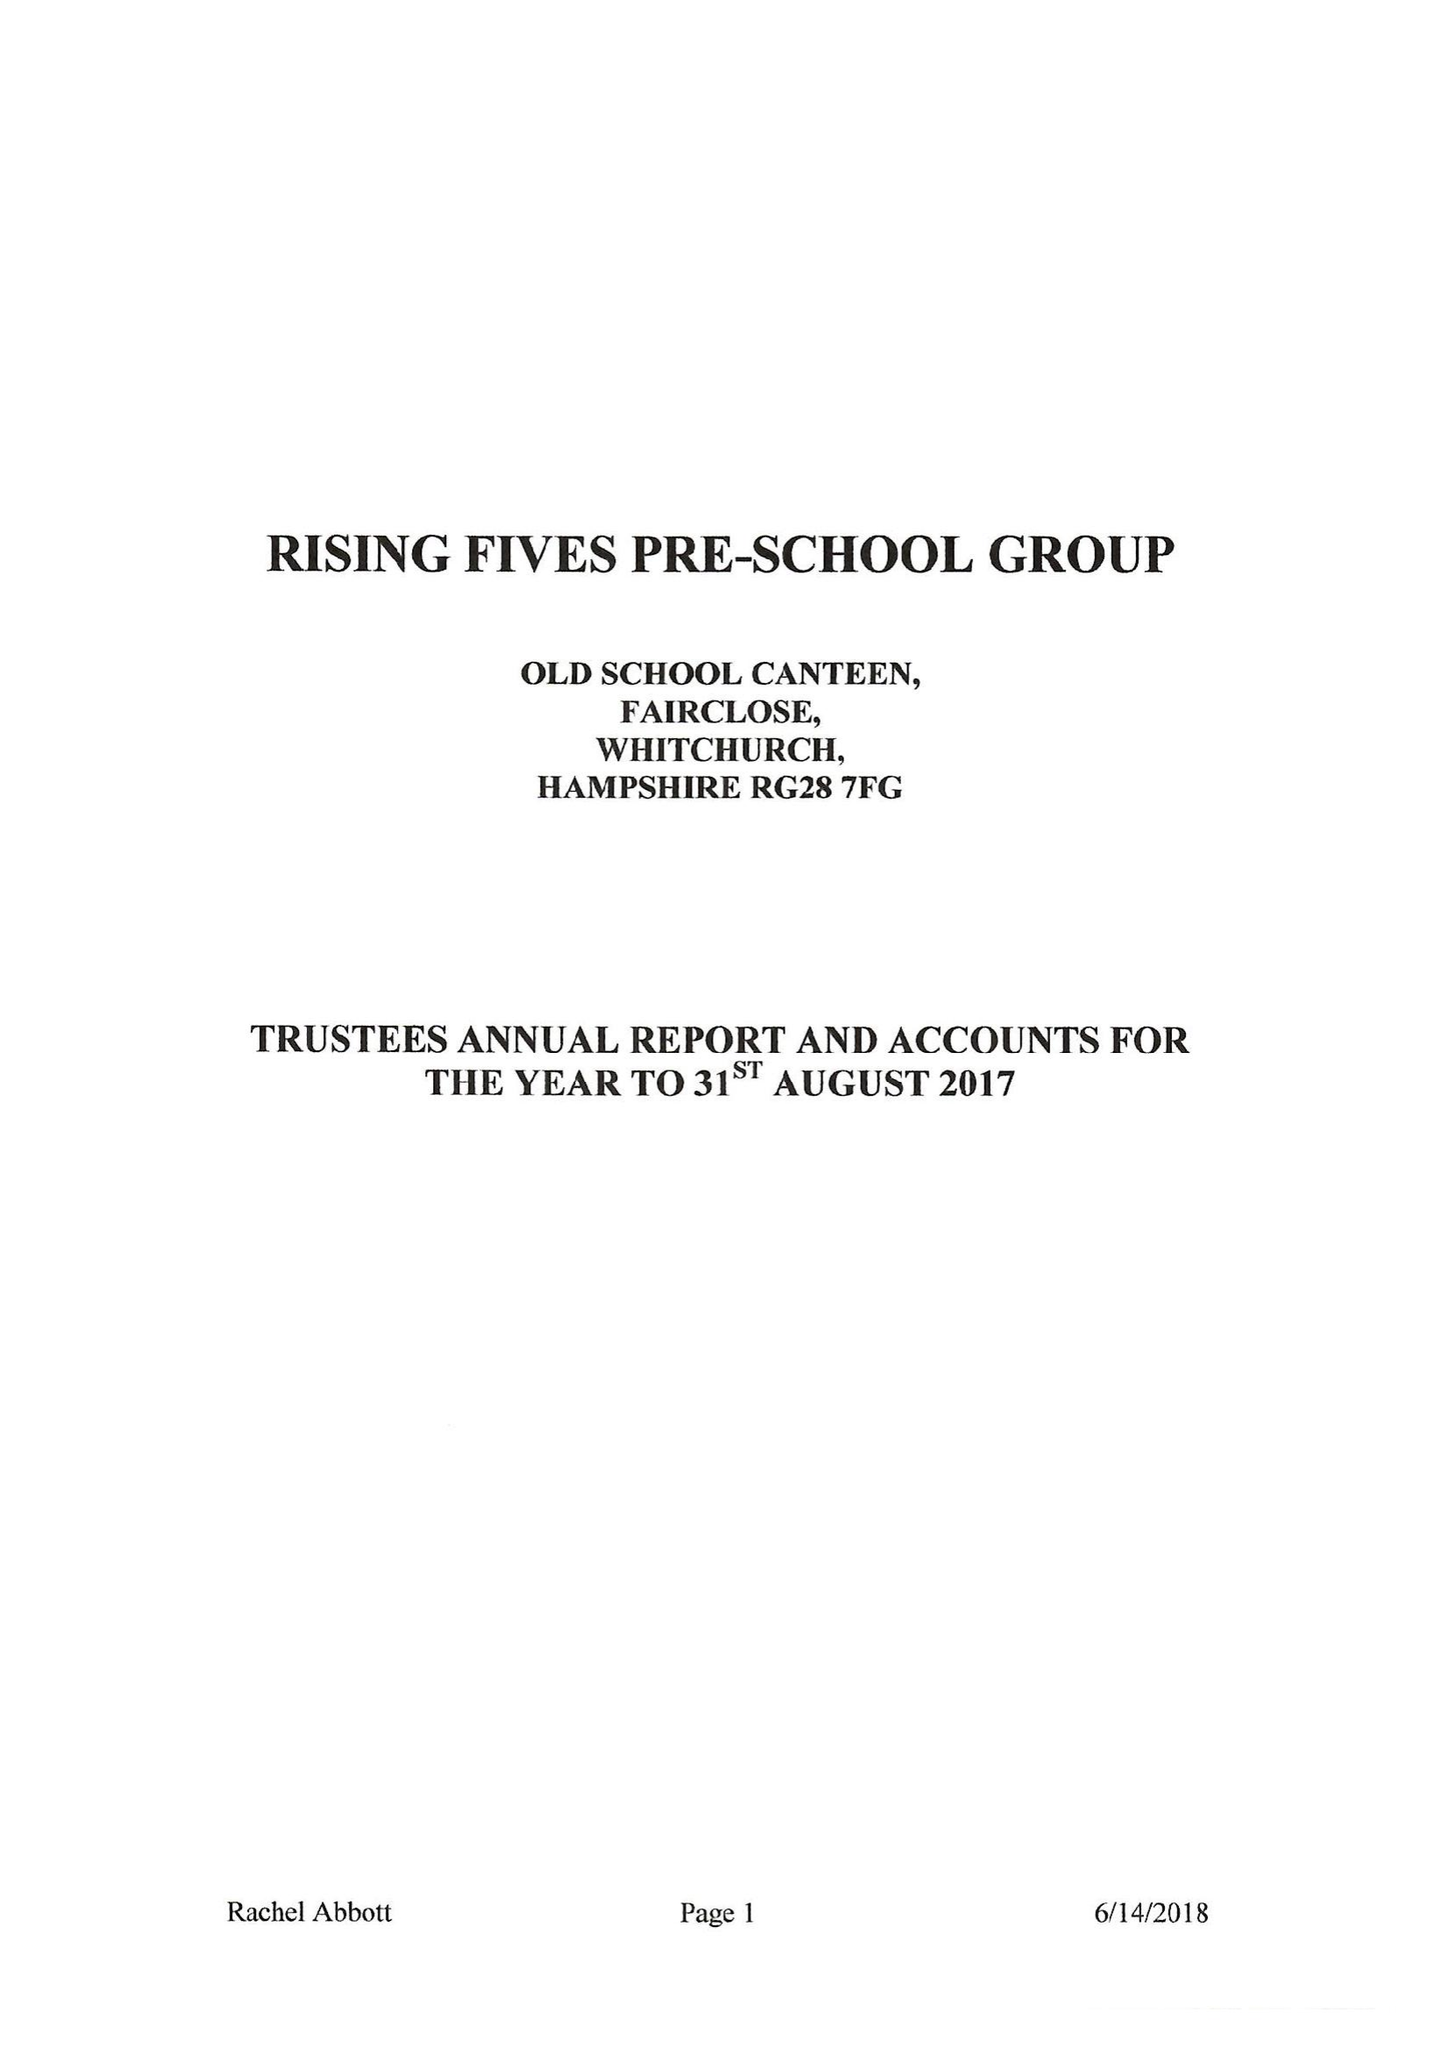What is the value for the income_annually_in_british_pounds?
Answer the question using a single word or phrase. 87748.00 